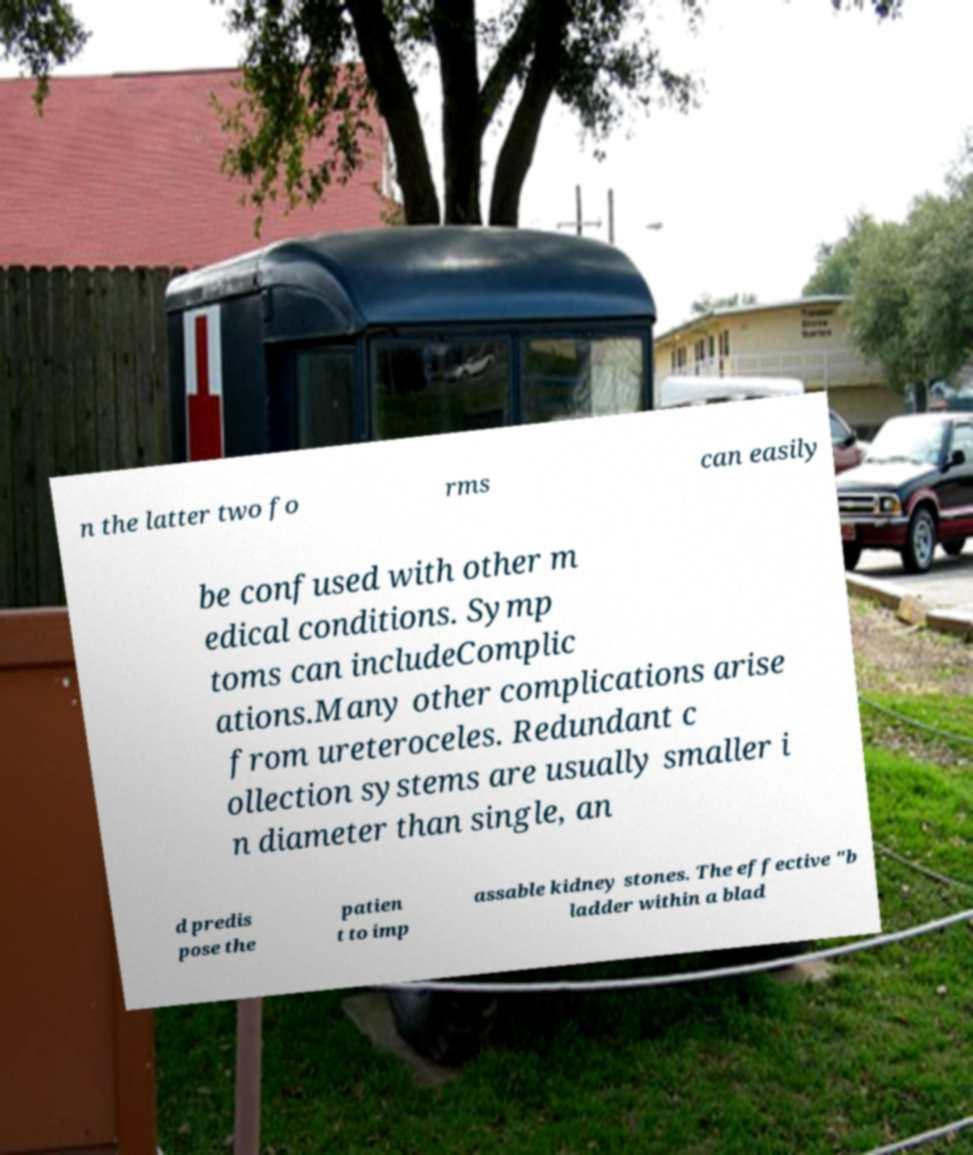Could you assist in decoding the text presented in this image and type it out clearly? n the latter two fo rms can easily be confused with other m edical conditions. Symp toms can includeComplic ations.Many other complications arise from ureteroceles. Redundant c ollection systems are usually smaller i n diameter than single, an d predis pose the patien t to imp assable kidney stones. The effective "b ladder within a blad 